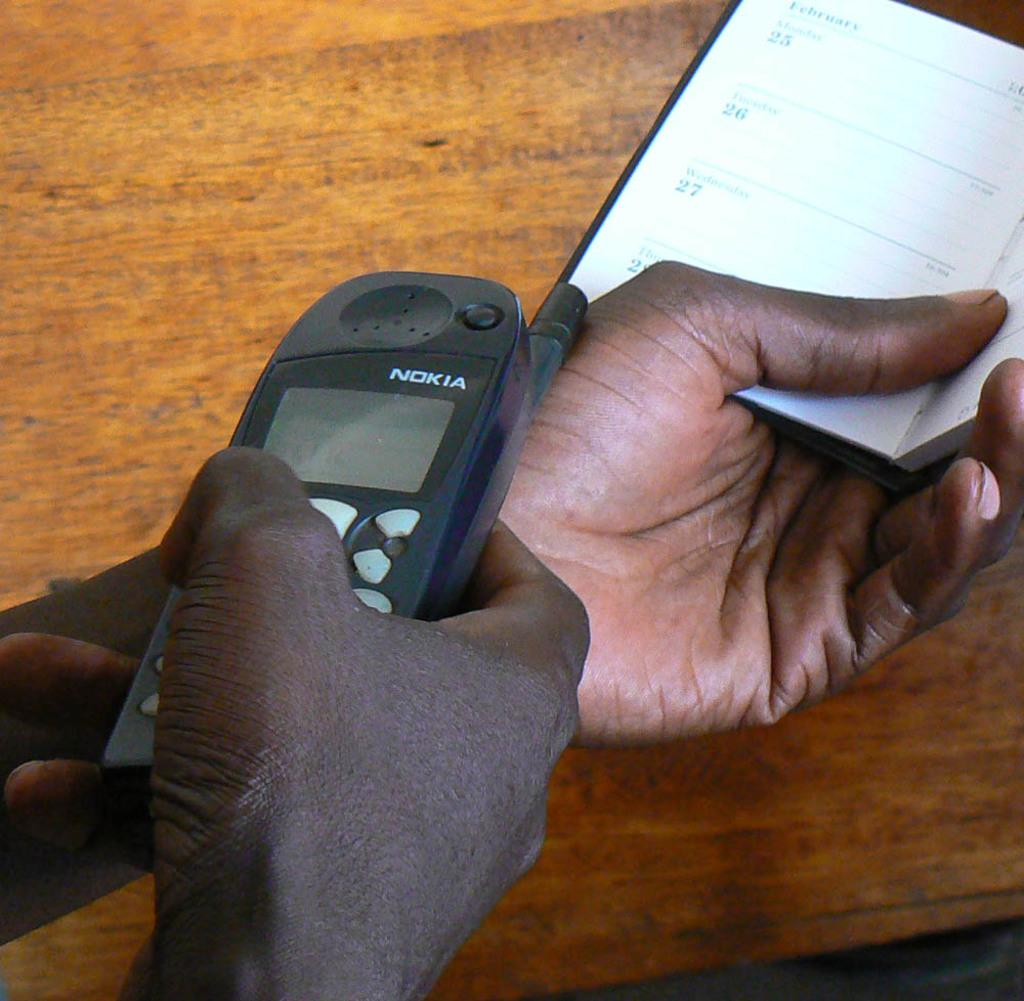Provide a one-sentence caption for the provided image. old nokia black cell phone in somebodys house. 